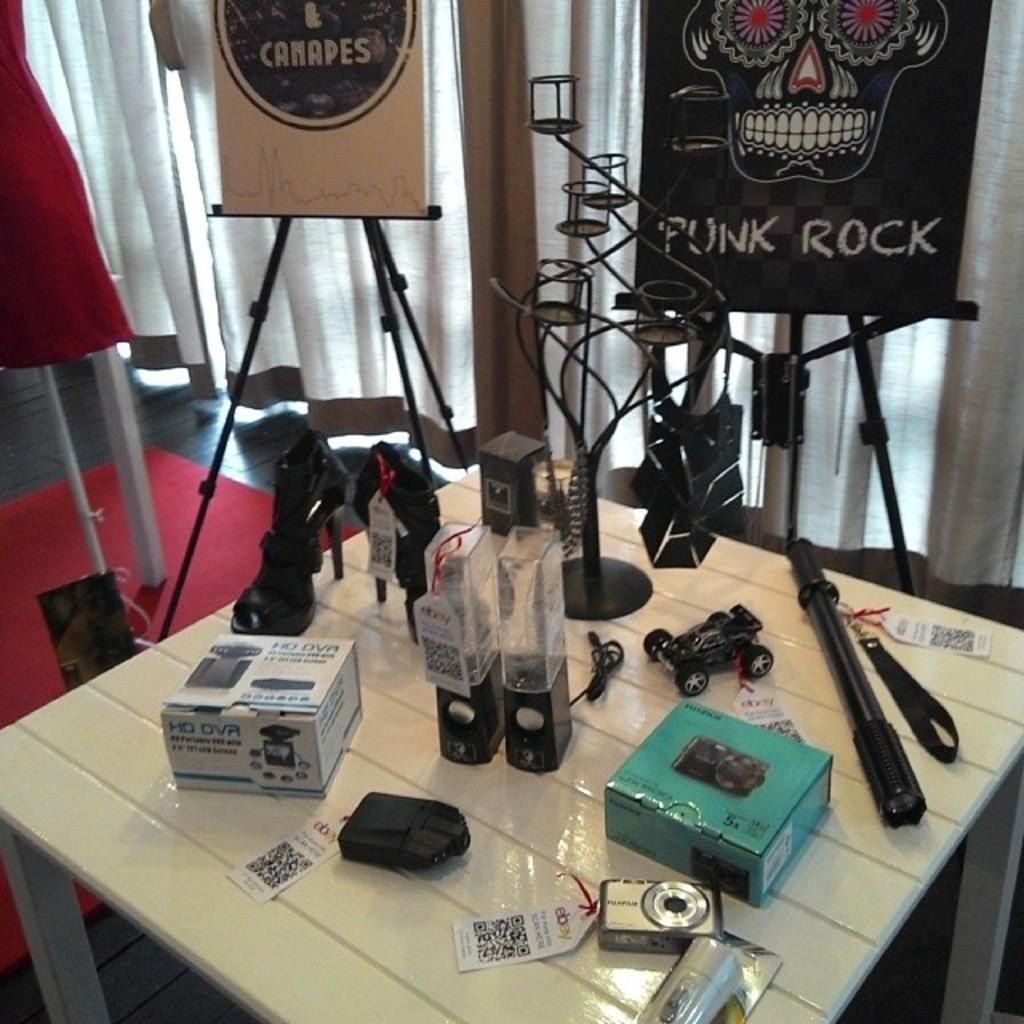How would you summarize this image in a sentence or two? At the bottom of the image there is a table with footwear, camera, box and many other things with tags. Behind the table there are stands with posters. On the posters there are images and text on it. In the background there are curtains. On the left side of the image there is a stand with cloth. 